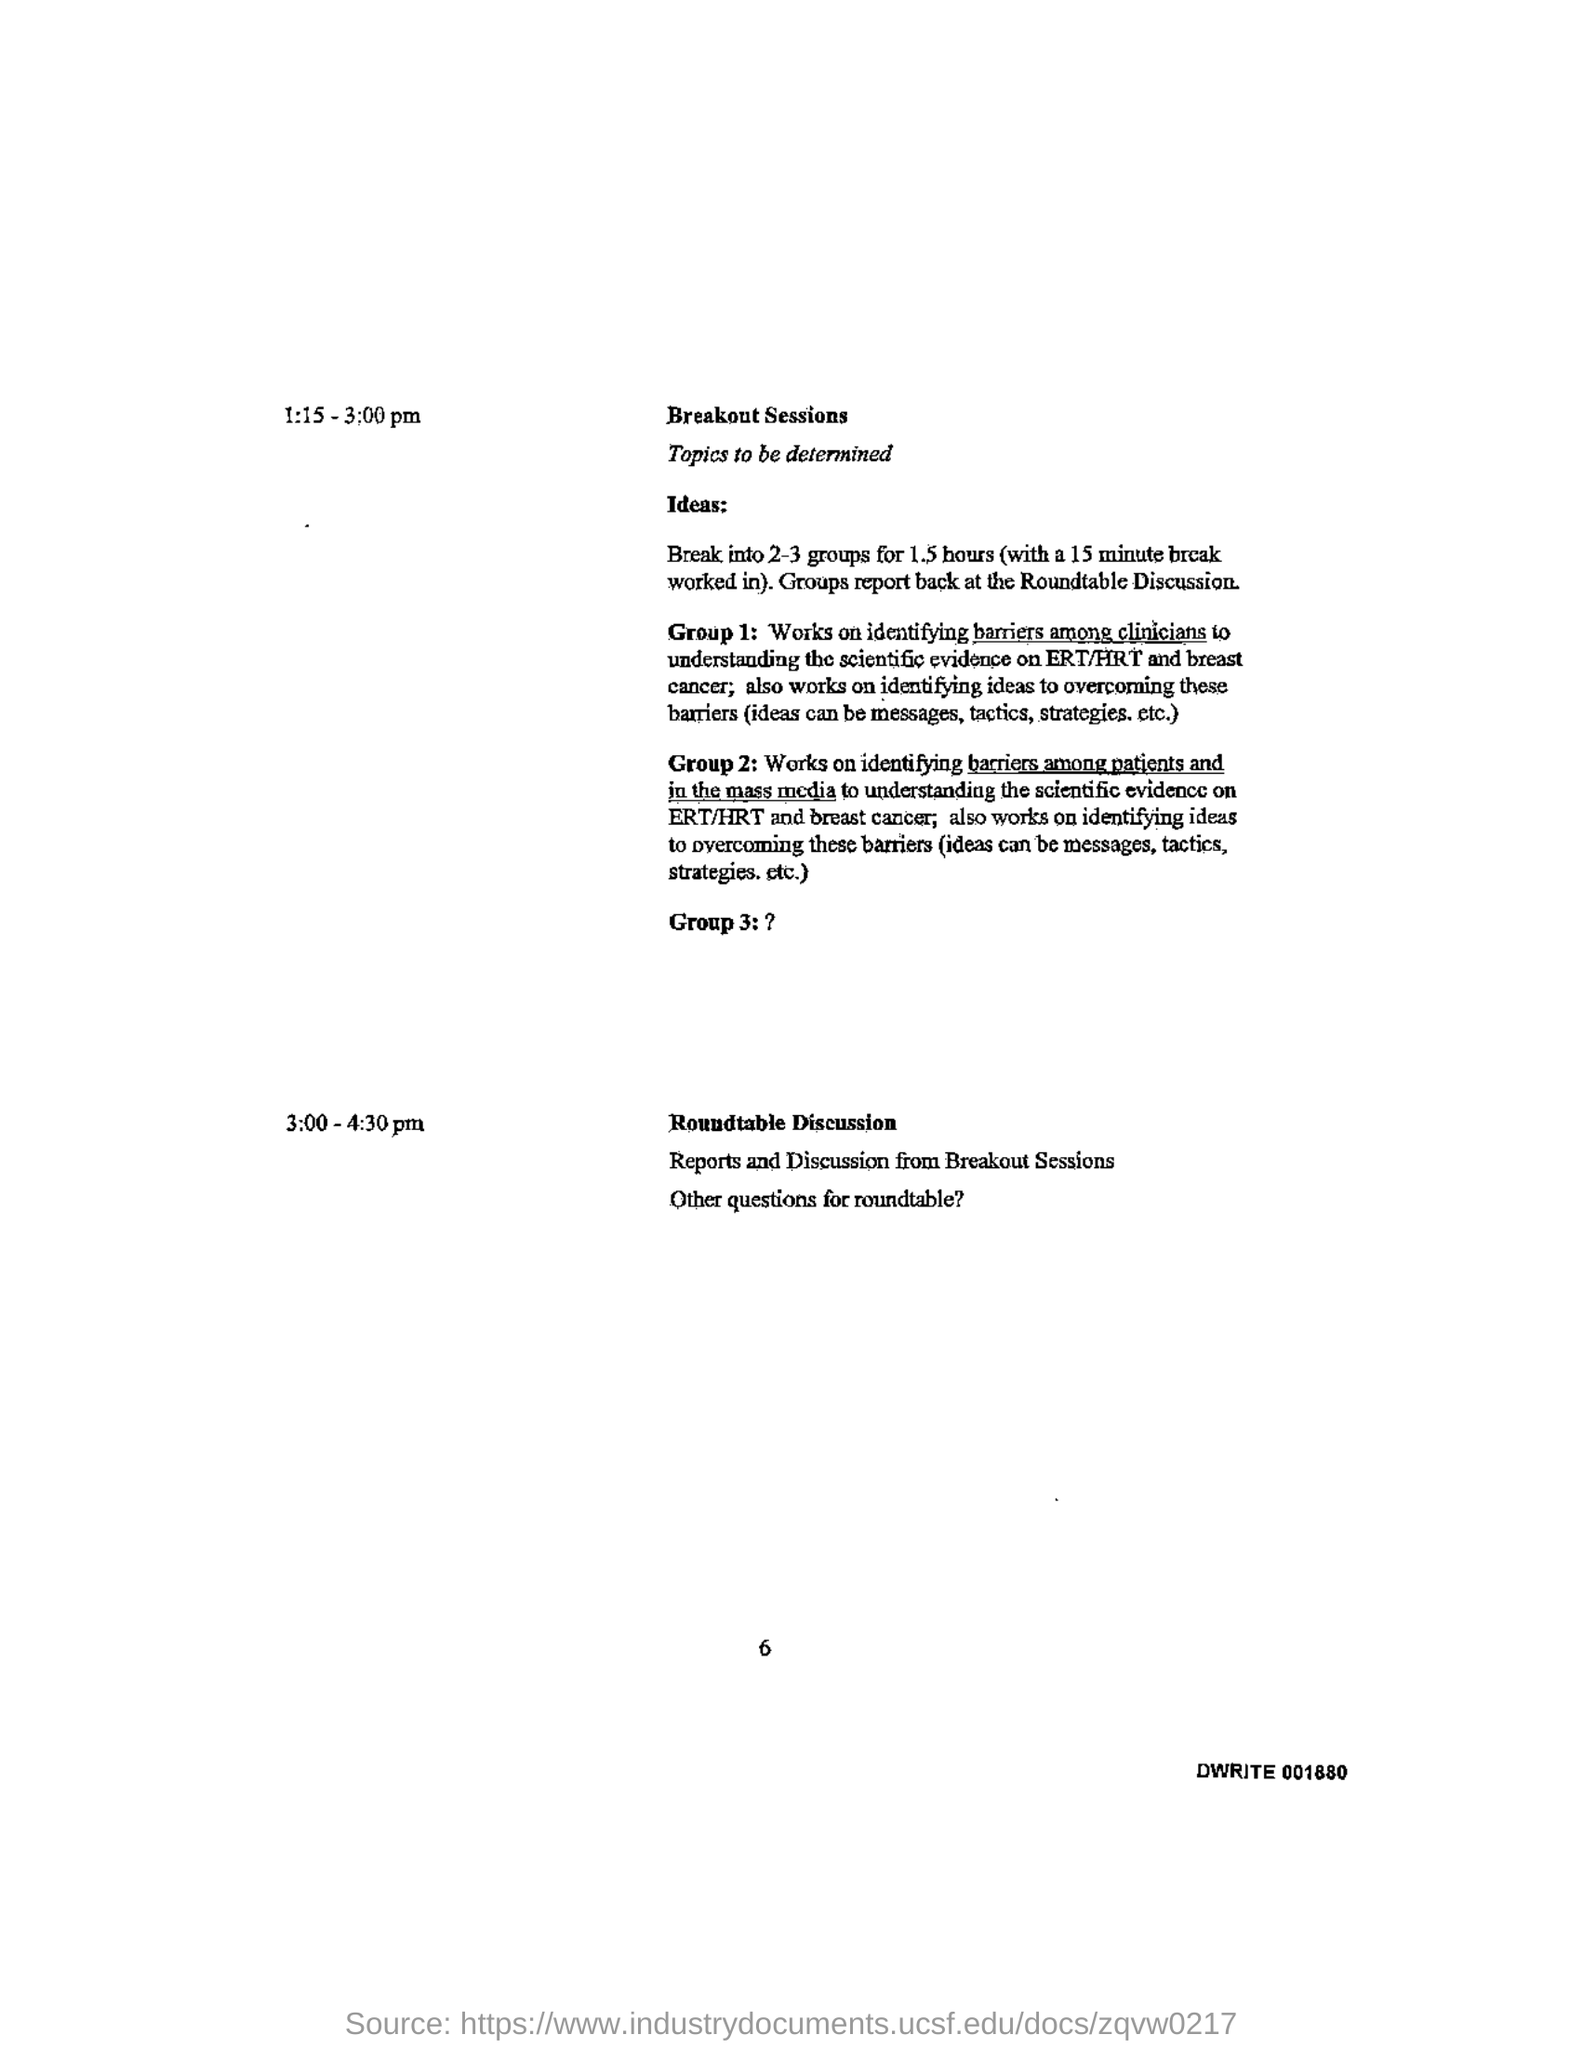What time is the roundtable discussion scheduled?
Your answer should be compact. 3:00 - 4:30 pm. What time is the breakout sessions scheduled?
Keep it short and to the point. 1:15 - 3:00 pm. 